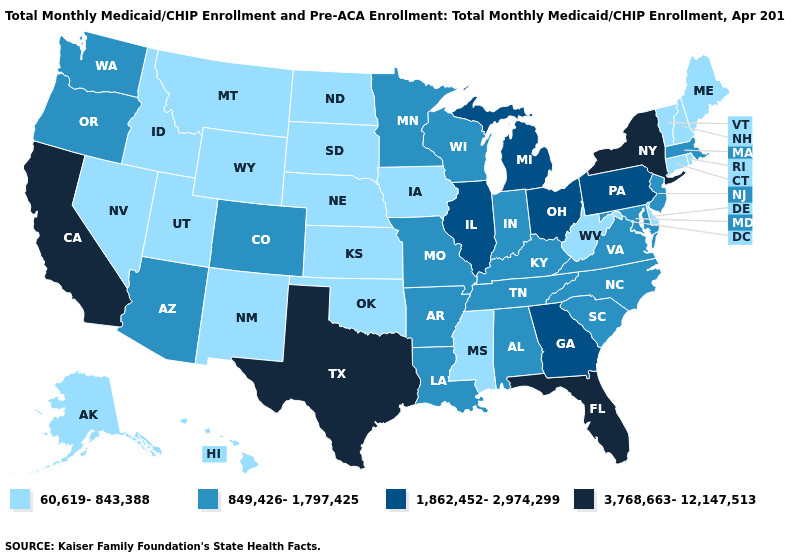Name the states that have a value in the range 3,768,663-12,147,513?
Be succinct. California, Florida, New York, Texas. Does the first symbol in the legend represent the smallest category?
Short answer required. Yes. What is the value of Tennessee?
Answer briefly. 849,426-1,797,425. What is the value of Maine?
Keep it brief. 60,619-843,388. Among the states that border New Jersey , which have the lowest value?
Concise answer only. Delaware. What is the value of Kansas?
Be succinct. 60,619-843,388. Does Alaska have the lowest value in the West?
Answer briefly. Yes. Does New Mexico have a lower value than Michigan?
Short answer required. Yes. Among the states that border Vermont , does New Hampshire have the lowest value?
Short answer required. Yes. What is the value of Minnesota?
Short answer required. 849,426-1,797,425. Which states hav the highest value in the South?
Give a very brief answer. Florida, Texas. What is the value of West Virginia?
Answer briefly. 60,619-843,388. Does Kansas have the lowest value in the USA?
Be succinct. Yes. What is the value of Montana?
Give a very brief answer. 60,619-843,388. What is the value of Nevada?
Short answer required. 60,619-843,388. 